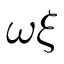<formula> <loc_0><loc_0><loc_500><loc_500>\omega \xi</formula> 